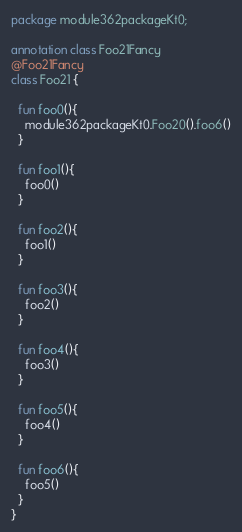<code> <loc_0><loc_0><loc_500><loc_500><_Kotlin_>package module362packageKt0;

annotation class Foo21Fancy
@Foo21Fancy
class Foo21 {

  fun foo0(){
    module362packageKt0.Foo20().foo6()
  }

  fun foo1(){
    foo0()
  }

  fun foo2(){
    foo1()
  }

  fun foo3(){
    foo2()
  }

  fun foo4(){
    foo3()
  }

  fun foo5(){
    foo4()
  }

  fun foo6(){
    foo5()
  }
}</code> 